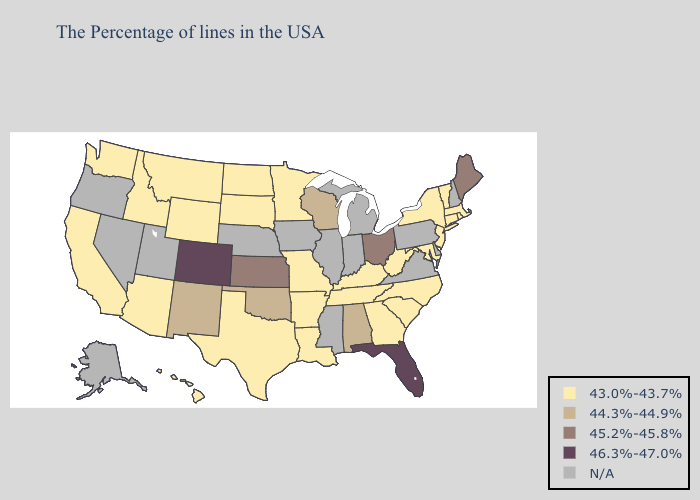Name the states that have a value in the range 45.2%-45.8%?
Write a very short answer. Maine, Ohio, Kansas. Name the states that have a value in the range 46.3%-47.0%?
Keep it brief. Florida, Colorado. Does Connecticut have the highest value in the Northeast?
Be succinct. No. Which states have the highest value in the USA?
Write a very short answer. Florida, Colorado. Name the states that have a value in the range 46.3%-47.0%?
Give a very brief answer. Florida, Colorado. Which states have the highest value in the USA?
Answer briefly. Florida, Colorado. Does the first symbol in the legend represent the smallest category?
Be succinct. Yes. What is the value of Iowa?
Concise answer only. N/A. Name the states that have a value in the range 44.3%-44.9%?
Answer briefly. Alabama, Wisconsin, Oklahoma, New Mexico. What is the value of Missouri?
Give a very brief answer. 43.0%-43.7%. Which states have the lowest value in the MidWest?
Write a very short answer. Missouri, Minnesota, South Dakota, North Dakota. Does the first symbol in the legend represent the smallest category?
Short answer required. Yes. Does the map have missing data?
Quick response, please. Yes. Which states have the lowest value in the MidWest?
Short answer required. Missouri, Minnesota, South Dakota, North Dakota. What is the lowest value in the USA?
Write a very short answer. 43.0%-43.7%. 